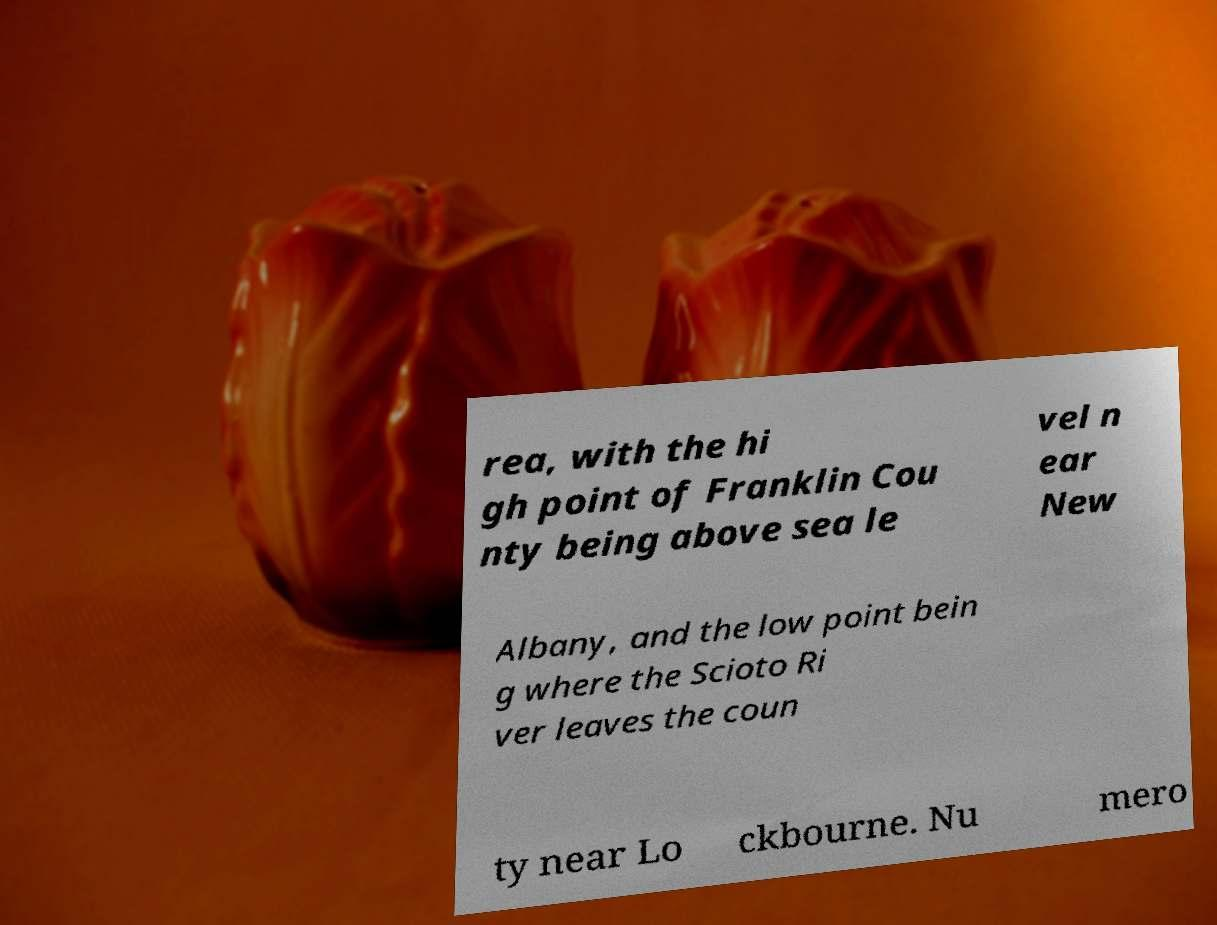Please identify and transcribe the text found in this image. rea, with the hi gh point of Franklin Cou nty being above sea le vel n ear New Albany, and the low point bein g where the Scioto Ri ver leaves the coun ty near Lo ckbourne. Nu mero 